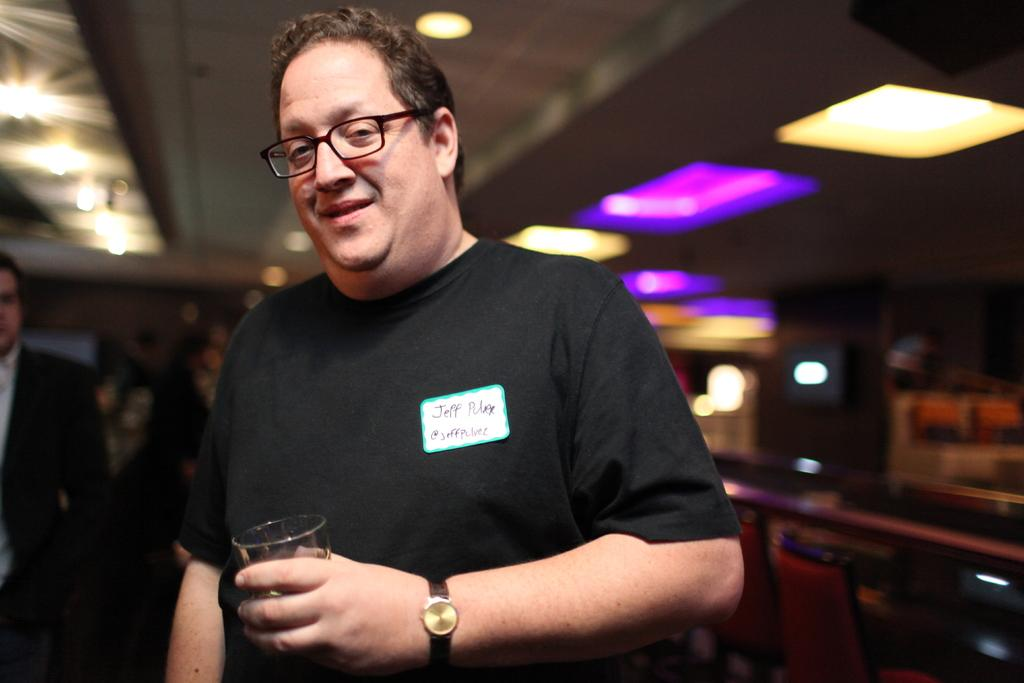What is the main subject in the foreground of the image? There is a person in the foreground of the image. What is the person wearing? The person is wearing a black t-shirt. What object is the person holding? The person is holding a glass. How many kittens are sleeping on the person's lap in the image? There are no kittens present in the image, and therefore no kittens can be seen sleeping on the person's lap. 